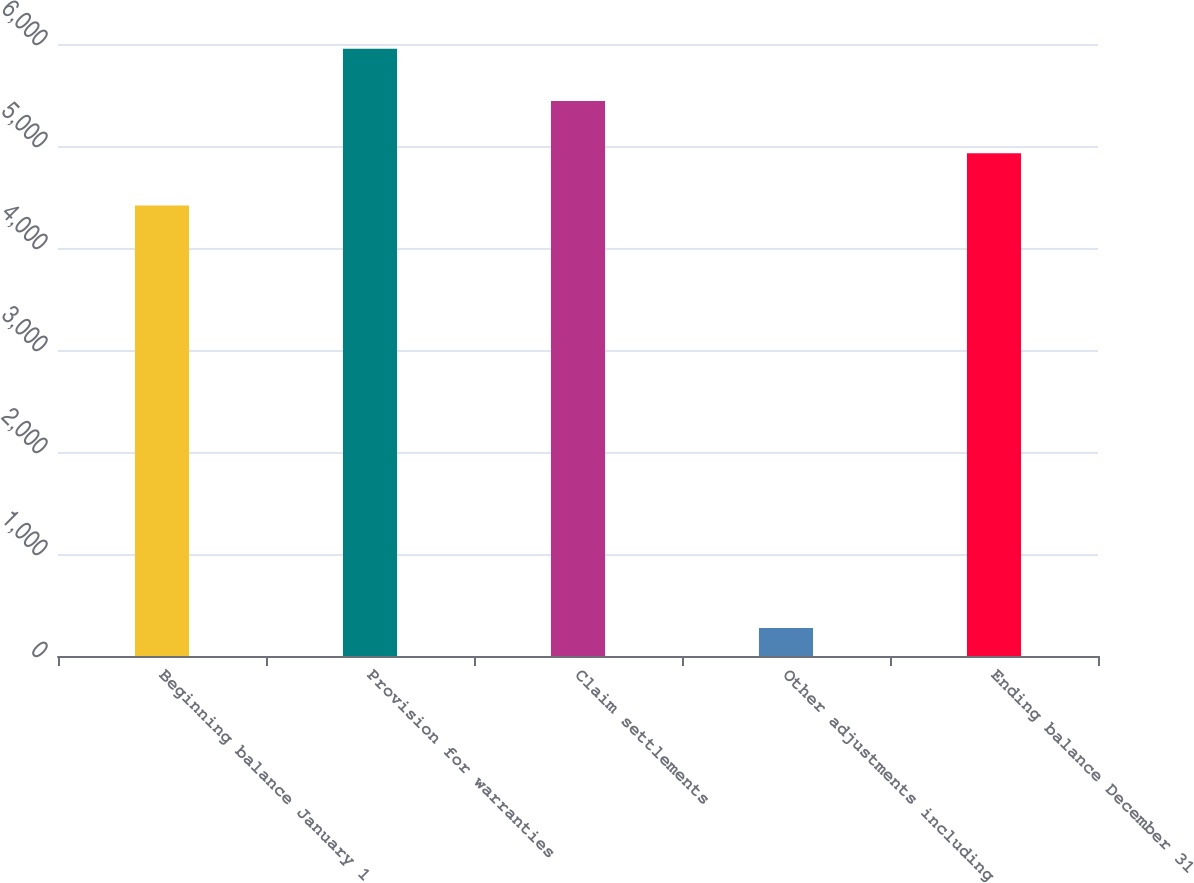Convert chart. <chart><loc_0><loc_0><loc_500><loc_500><bar_chart><fcel>Beginning balance January 1<fcel>Provision for warranties<fcel>Claim settlements<fcel>Other adjustments including<fcel>Ending balance December 31<nl><fcel>4417<fcel>5954.2<fcel>5441.8<fcel>274<fcel>4929.4<nl></chart> 